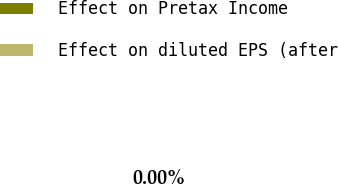Convert chart. <chart><loc_0><loc_0><loc_500><loc_500><pie_chart><fcel>Effect on Pretax Income<fcel>Effect on diluted EPS (after<nl><fcel>100.0%<fcel>0.0%<nl></chart> 